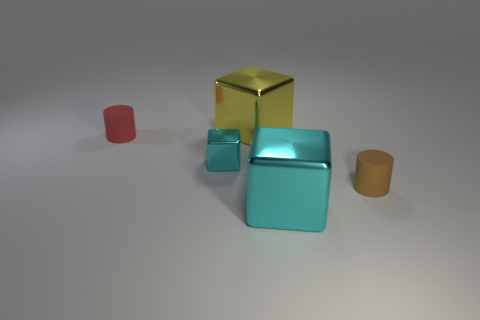Add 1 big brown cylinders. How many objects exist? 6 Subtract all cylinders. How many objects are left? 3 Subtract 0 yellow spheres. How many objects are left? 5 Subtract all large cyan metal objects. Subtract all large cubes. How many objects are left? 2 Add 4 yellow shiny blocks. How many yellow shiny blocks are left? 5 Add 1 yellow things. How many yellow things exist? 2 